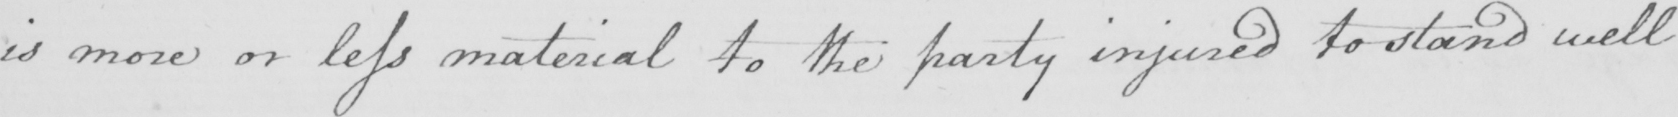What is written in this line of handwriting? is more or less material to the party injured to stand well 